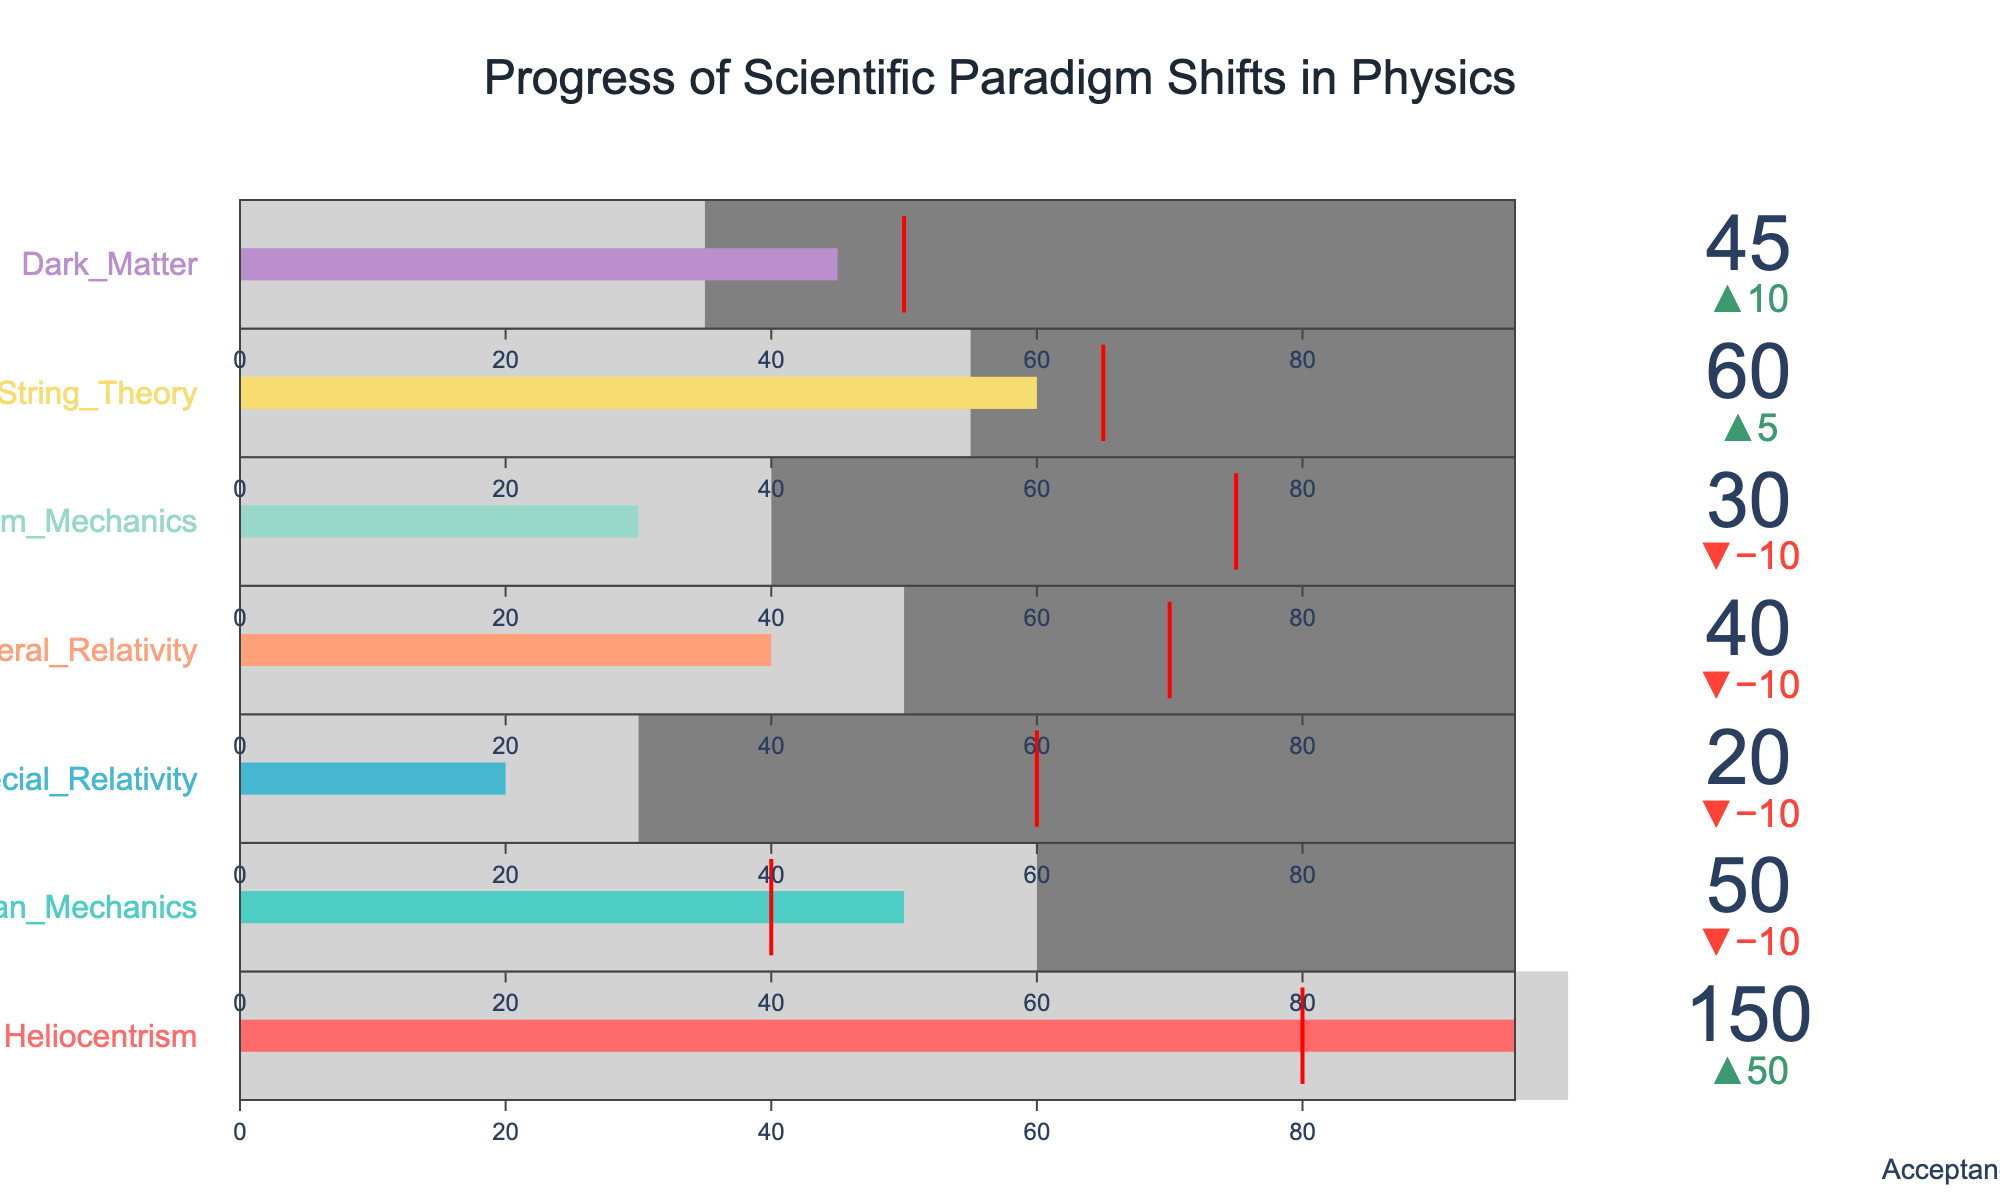What's the title of the figure? The title is usually placed at the top of the figure, written in a larger font size. Here, the title "Progress of Scientific Paradigm Shifts in Physics" is clearly visible at the top center.
Answer: Progress of Scientific Paradigm Shifts in Physics How many paradigms are included in the figure? The figure includes one bullet chart for each paradigm. By counting the bullet charts, you can determine the number of paradigms. There are seven paradigms listed in the data.
Answer: 7 Which scientific paradigm took the longest time to be accepted? Look for the bullet chart with the highest "Acceptance_Time" value. The "Heliocentrism" paradigm has the highest value of 150 years, indicating it took the longest time to be accepted.
Answer: Heliocentrism What is the average acceptance time across all paradigms? To find the average, sum all the "Acceptance_Time" values and divide by the number of paradigms. The sum is (150 + 50 + 20 + 40 + 30 + 60 + 45) = 395, and there are 7 paradigms. So, 395 / 7 ≈ 56.43.
Answer: 56.43 Which scientific paradigm faced the highest historical resistance? Check the "Historical_Resistance" values in the bullet charts. The "Heliocentrism" paradigm has the highest historical resistance value of 80.
Answer: Heliocentrism How does the acceptance time of String Theory compare to its historical resistance? Compare the values directly: String Theory's "Acceptance_Time" is 60 years, and its "Historical_Resistance" is 65. Acceptance time is slightly lower.
Answer: 60 vs 65 Which paradigm had less acceptance time than its average acceptance but faced higher historical resistance compared to the average acceptance? Check each paradigm's bullet chart where the "Acceptance_Time" is less than the "Average_Acceptance" but the "Historical_Resistance" is greater than the "Average_Acceptance". This applies to "Special Relativity" (20 < 30 and 60 > 30).
Answer: Special Relativity What is the relationship between acceptance time and historical resistance for General Relativity? Compare the values: General Relativity's "Acceptance_Time" is 40 years, and its "Historical_Resistance" is 70. Historical resistance is significantly higher than acceptance time.
Answer: 40 vs 70 How many paradigms have an acceptance time longer than 50 years? Count the bullet charts where the "Acceptance_Time" value is greater than 50. They are Heliocentrism (150), String Theory (60), and Newtonian Mechanics (50). There are 3 paradigms.
Answer: 3 If we rank paradigms by acceptance time, which one comes in third place? Rank the paradigms by their "Acceptance_Time" values. The third highest value is provided for Dark Matter at 45 years. The ranks are: Heliocentrism (150), String Theory (60), and Dark Matter (45).
Answer: Dark Matter 